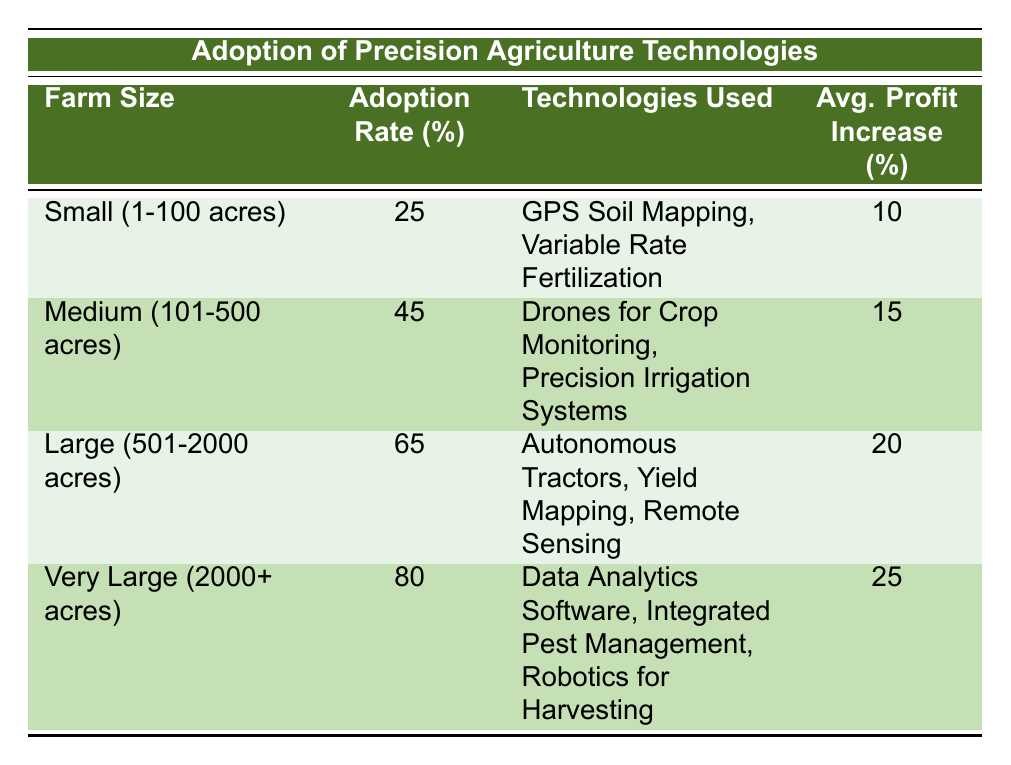What is the adoption rate for small farms? The table lists the adoption rate of precision agriculture technologies for small farms (1-100 acres) as 25%.
Answer: 25% Which farm size has the highest average profit increase percentage? According to the table, very large farms (2000+ acres) have the highest average profit increase percentage, which is 25%.
Answer: Very Large (2000+ acres) How many technologies are used by large farms? The table indicates that large farms (501-2000 acres) use three technologies: Autonomous Tractors, Yield Mapping, and Remote Sensing.
Answer: 3 What is the difference in adoption rates between medium and very large farms? The adoption rate for medium farms (101-500 acres) is 45%, while for very large farms (2000+ acres) it is 80%. Thus, the difference is 80 - 45 = 35%.
Answer: 35% Are there any technologies used by small farms that are also used by medium farms? Looking at the table, there are no technologies listed that are common between small farms (GPS Soil Mapping, Variable Rate Fertilization) and medium farms (Drones for Crop Monitoring, Precision Irrigation Systems). Therefore, the answer is no.
Answer: No What is the average profit increase for medium-sized farms compared to small-sized farms? The average profit increase for medium farms is 15%, and for small farms, it is 10%. Thus, the average profit increase for medium-sized farms is higher by 15% - 10% = 5%.
Answer: 5% Which farm size utilizes data analytics software? The table shows that only very large farms (2000+ acres) utilize data analytics software as part of their technologies used for precision agriculture.
Answer: Very Large (2000+ acres) What percentage of large farms adopt precision agriculture technologies? The table reveals that large farms (501-2000 acres) have an adoption rate of 65% for precision agriculture technologies.
Answer: 65% 